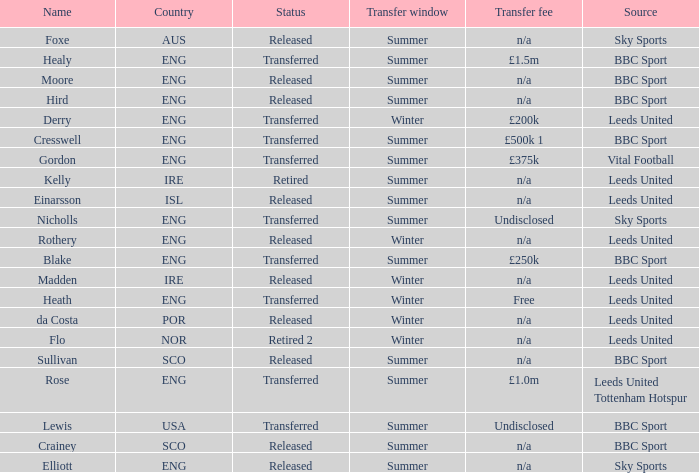What was the transfer fee for the summer transfer involving the SCO named Crainey? N/a. 